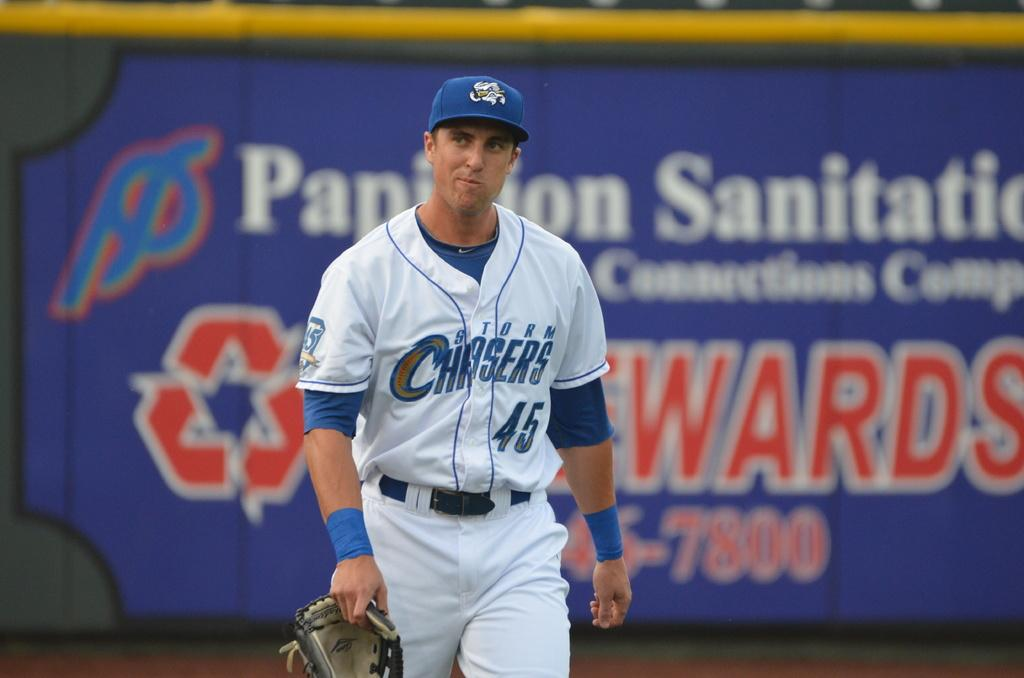<image>
Present a compact description of the photo's key features. A baseball player in a Storm Chasers shirts holding a mitt 